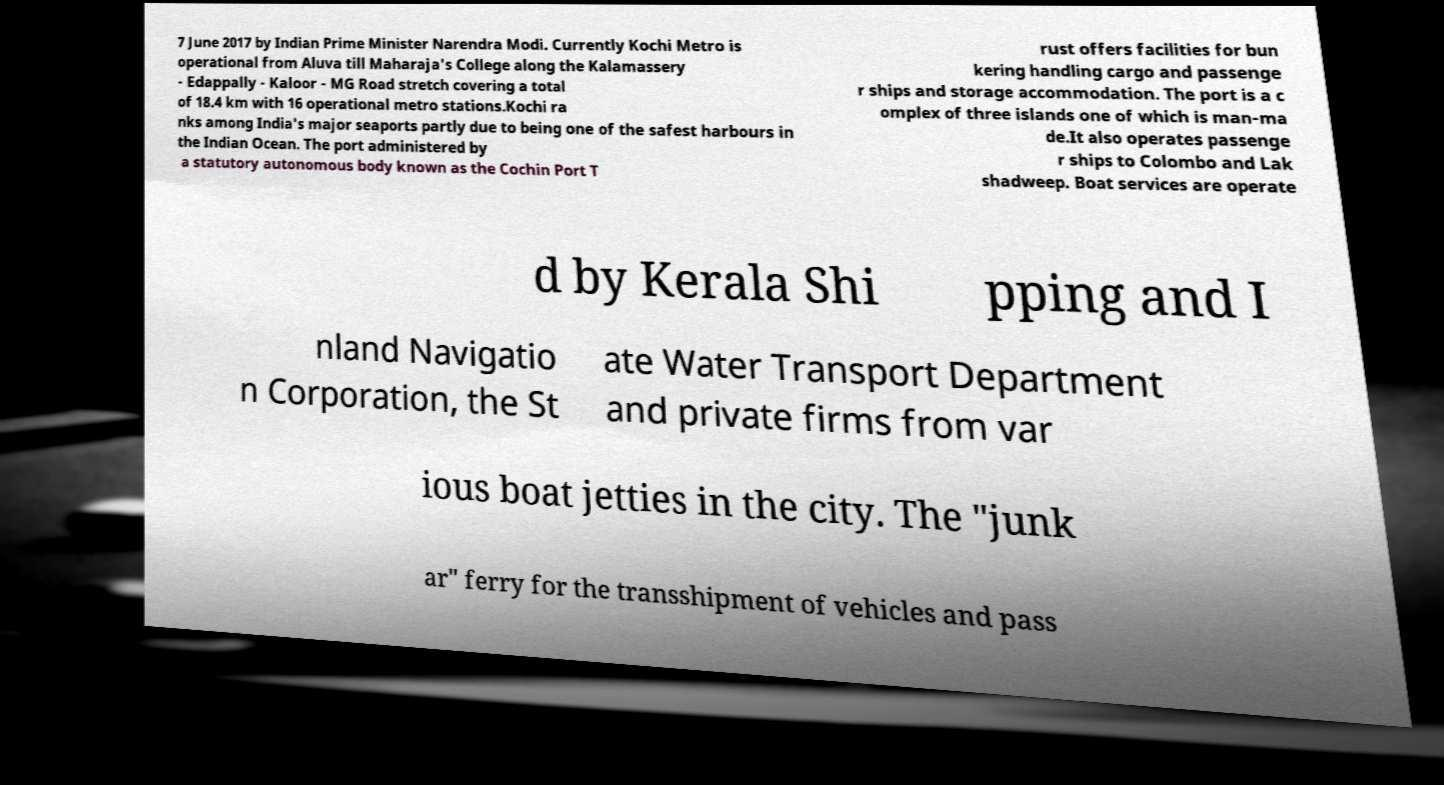Could you assist in decoding the text presented in this image and type it out clearly? 7 June 2017 by Indian Prime Minister Narendra Modi. Currently Kochi Metro is operational from Aluva till Maharaja's College along the Kalamassery - Edappally - Kaloor - MG Road stretch covering a total of 18.4 km with 16 operational metro stations.Kochi ra nks among India's major seaports partly due to being one of the safest harbours in the Indian Ocean. The port administered by a statutory autonomous body known as the Cochin Port T rust offers facilities for bun kering handling cargo and passenge r ships and storage accommodation. The port is a c omplex of three islands one of which is man-ma de.It also operates passenge r ships to Colombo and Lak shadweep. Boat services are operate d by Kerala Shi pping and I nland Navigatio n Corporation, the St ate Water Transport Department and private firms from var ious boat jetties in the city. The "junk ar" ferry for the transshipment of vehicles and pass 